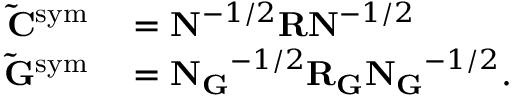Convert formula to latex. <formula><loc_0><loc_0><loc_500><loc_500>\begin{array} { r l } { \tilde { C } ^ { s y m } } & = N ^ { - 1 / 2 } R N ^ { - 1 / 2 } } \\ { \tilde { G } ^ { s y m } } & = N _ { G } ^ { - 1 / 2 } R _ { G } N _ { G } ^ { - 1 / 2 } . } \end{array}</formula> 